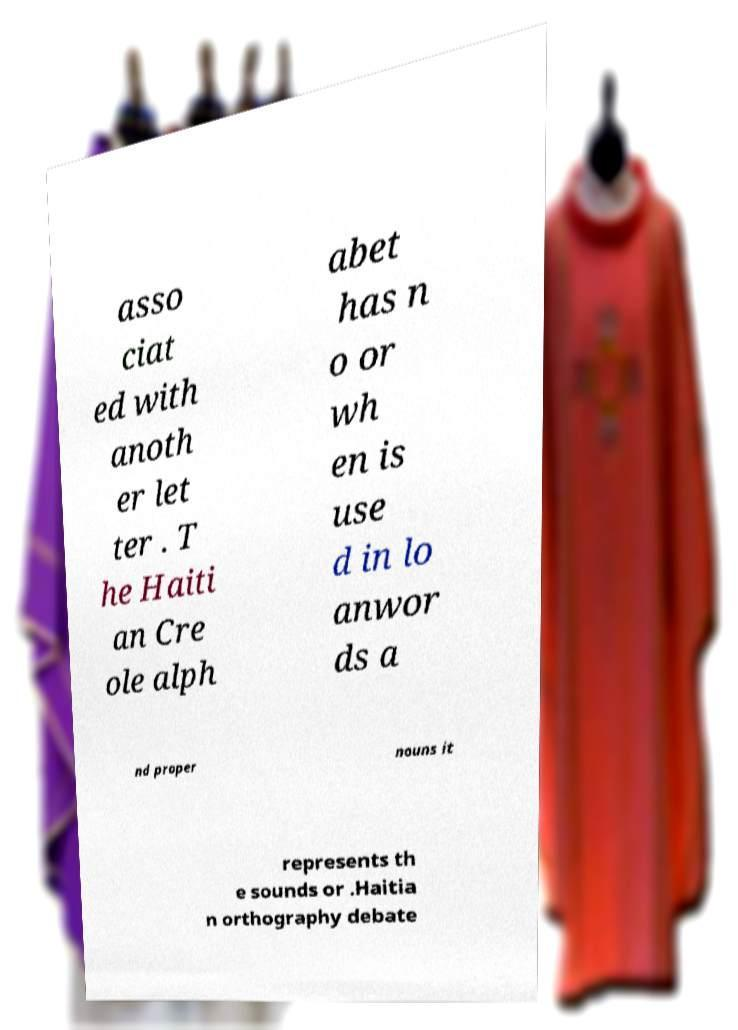Can you accurately transcribe the text from the provided image for me? asso ciat ed with anoth er let ter . T he Haiti an Cre ole alph abet has n o or wh en is use d in lo anwor ds a nd proper nouns it represents th e sounds or .Haitia n orthography debate 